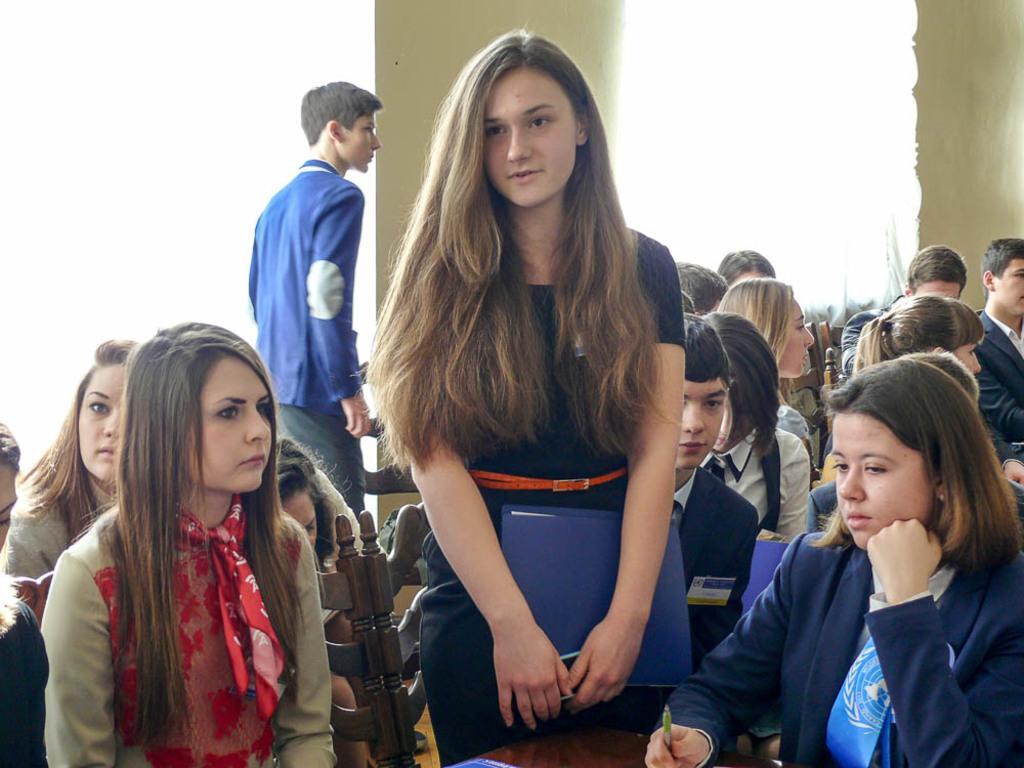Describe this image in one or two sentences. In the center of the image we can see two people are standing and a few people are sitting on the chairs. Among them, we can see two persons are holding some objects. In the background there is a wall. 